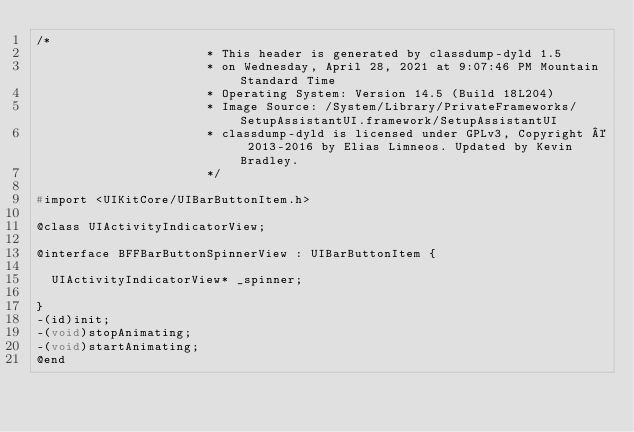<code> <loc_0><loc_0><loc_500><loc_500><_C_>/*
                       * This header is generated by classdump-dyld 1.5
                       * on Wednesday, April 28, 2021 at 9:07:46 PM Mountain Standard Time
                       * Operating System: Version 14.5 (Build 18L204)
                       * Image Source: /System/Library/PrivateFrameworks/SetupAssistantUI.framework/SetupAssistantUI
                       * classdump-dyld is licensed under GPLv3, Copyright © 2013-2016 by Elias Limneos. Updated by Kevin Bradley.
                       */

#import <UIKitCore/UIBarButtonItem.h>

@class UIActivityIndicatorView;

@interface BFFBarButtonSpinnerView : UIBarButtonItem {

	UIActivityIndicatorView* _spinner;

}
-(id)init;
-(void)stopAnimating;
-(void)startAnimating;
@end

</code> 